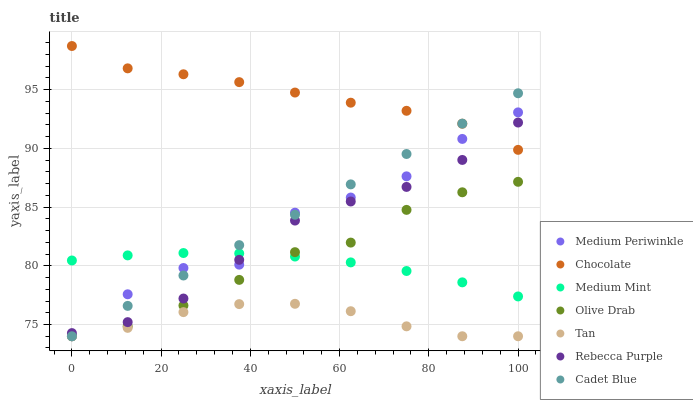Does Tan have the minimum area under the curve?
Answer yes or no. Yes. Does Chocolate have the maximum area under the curve?
Answer yes or no. Yes. Does Cadet Blue have the minimum area under the curve?
Answer yes or no. No. Does Cadet Blue have the maximum area under the curve?
Answer yes or no. No. Is Cadet Blue the smoothest?
Answer yes or no. Yes. Is Medium Periwinkle the roughest?
Answer yes or no. Yes. Is Medium Periwinkle the smoothest?
Answer yes or no. No. Is Cadet Blue the roughest?
Answer yes or no. No. Does Cadet Blue have the lowest value?
Answer yes or no. Yes. Does Chocolate have the lowest value?
Answer yes or no. No. Does Chocolate have the highest value?
Answer yes or no. Yes. Does Cadet Blue have the highest value?
Answer yes or no. No. Is Olive Drab less than Chocolate?
Answer yes or no. Yes. Is Chocolate greater than Olive Drab?
Answer yes or no. Yes. Does Medium Periwinkle intersect Tan?
Answer yes or no. Yes. Is Medium Periwinkle less than Tan?
Answer yes or no. No. Is Medium Periwinkle greater than Tan?
Answer yes or no. No. Does Olive Drab intersect Chocolate?
Answer yes or no. No. 